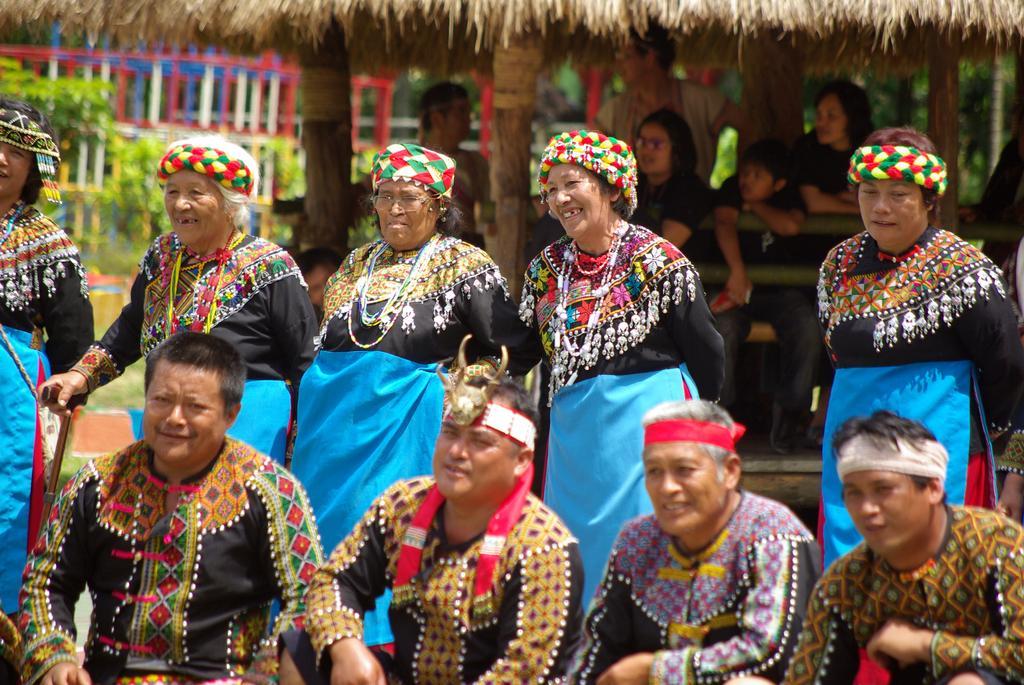Could you give a brief overview of what you see in this image? In this image there are four men sitting and five women are standing, in the background there is a hut, inside the hut there are people sitting and in the top left it is blurred. 